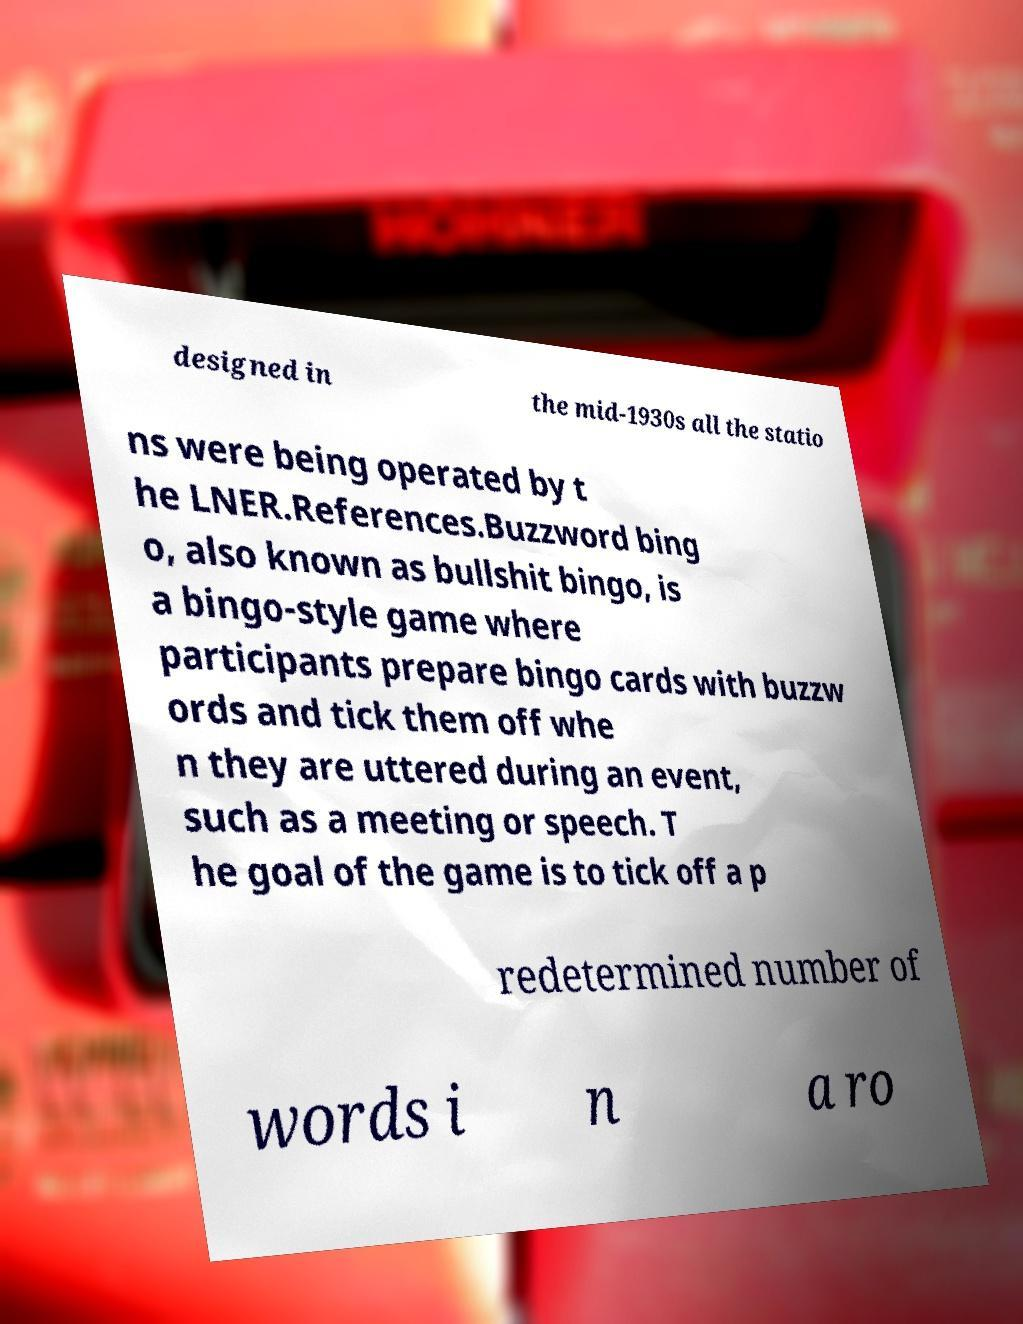For documentation purposes, I need the text within this image transcribed. Could you provide that? designed in the mid-1930s all the statio ns were being operated by t he LNER.References.Buzzword bing o, also known as bullshit bingo, is a bingo-style game where participants prepare bingo cards with buzzw ords and tick them off whe n they are uttered during an event, such as a meeting or speech. T he goal of the game is to tick off a p redetermined number of words i n a ro 